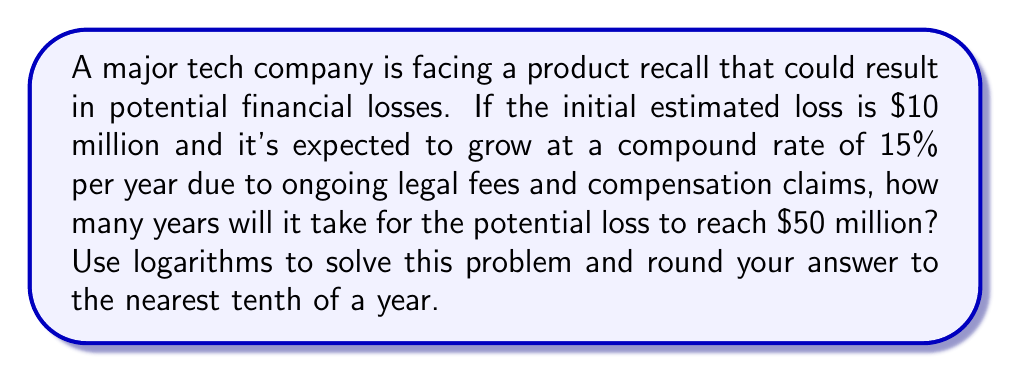Solve this math problem. Let's approach this step-by-step using the compound interest formula and logarithms:

1) The compound interest formula is:
   $A = P(1 + r)^t$
   Where:
   $A$ = Final amount
   $P$ = Principal (initial amount)
   $r$ = Interest rate (in decimal form)
   $t$ = Time in years

2) We know:
   $P = 10$ million
   $A = 50$ million
   $r = 0.15$ (15% in decimal form)

3) Plugging these into the formula:
   $50 = 10(1 + 0.15)^t$

4) Divide both sides by 10:
   $5 = (1.15)^t$

5) Take the natural log of both sides:
   $\ln(5) = \ln((1.15)^t)$

6) Use the logarithm property $\ln(a^b) = b\ln(a)$:
   $\ln(5) = t\ln(1.15)$

7) Solve for $t$:
   $t = \frac{\ln(5)}{\ln(1.15)}$

8) Calculate:
   $t = \frac{1.6094379124}{0.1397619126} \approx 11.5158$ years

9) Rounding to the nearest tenth:
   $t \approx 11.5$ years
Answer: 11.5 years 